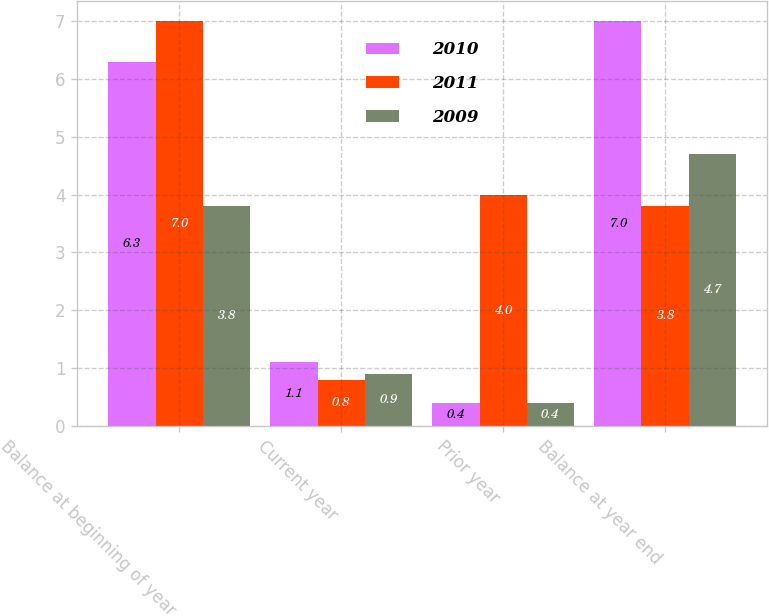Convert chart to OTSL. <chart><loc_0><loc_0><loc_500><loc_500><stacked_bar_chart><ecel><fcel>Balance at beginning of year<fcel>Current year<fcel>Prior year<fcel>Balance at year end<nl><fcel>2010<fcel>6.3<fcel>1.1<fcel>0.4<fcel>7<nl><fcel>2011<fcel>7<fcel>0.8<fcel>4<fcel>3.8<nl><fcel>2009<fcel>3.8<fcel>0.9<fcel>0.4<fcel>4.7<nl></chart> 